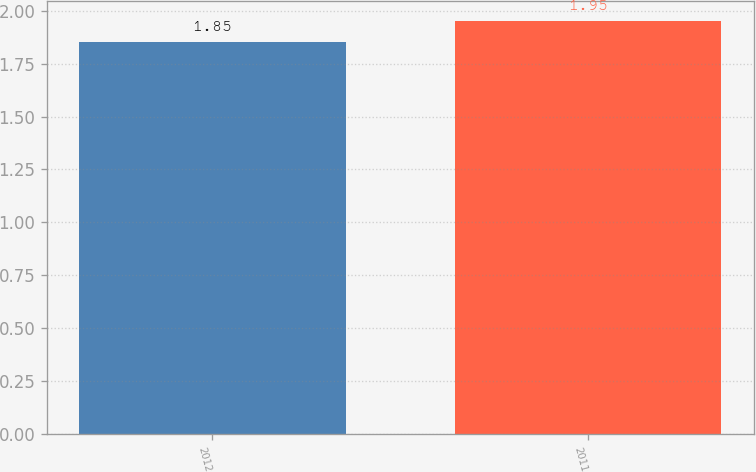<chart> <loc_0><loc_0><loc_500><loc_500><bar_chart><fcel>2012<fcel>2011<nl><fcel>1.85<fcel>1.95<nl></chart> 